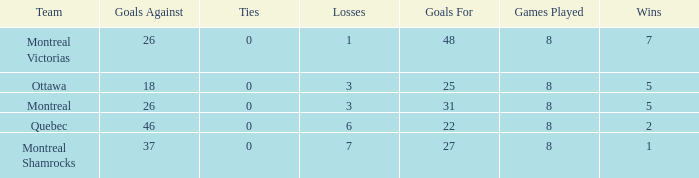How many losses did the team with 22 goals for andmore than 8 games played have? 0.0. 